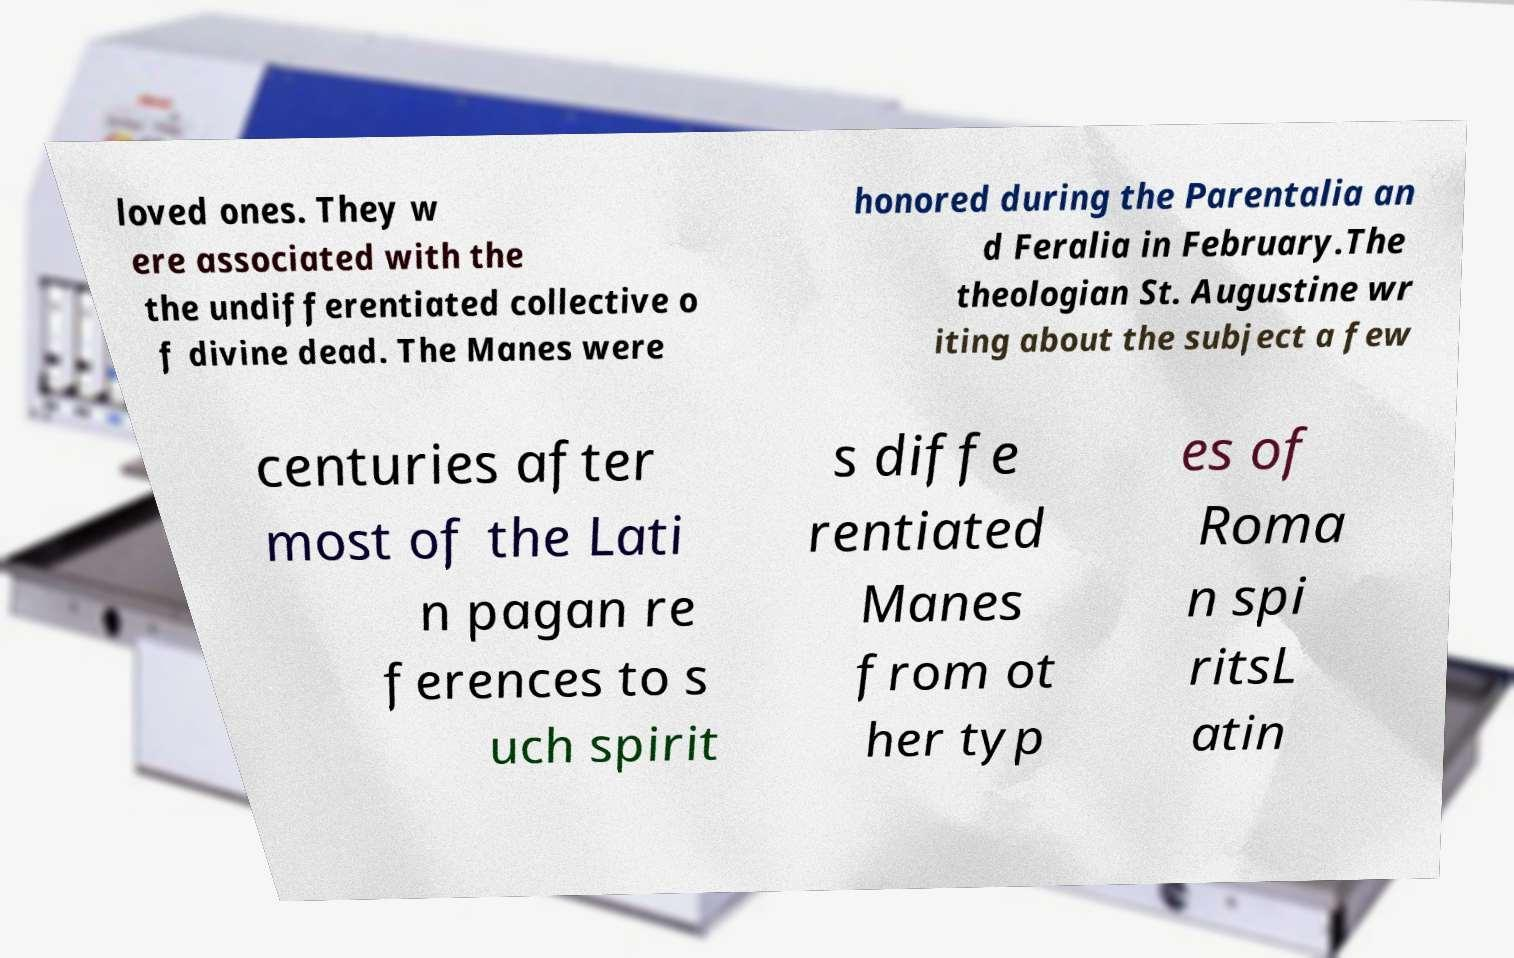There's text embedded in this image that I need extracted. Can you transcribe it verbatim? loved ones. They w ere associated with the the undifferentiated collective o f divine dead. The Manes were honored during the Parentalia an d Feralia in February.The theologian St. Augustine wr iting about the subject a few centuries after most of the Lati n pagan re ferences to s uch spirit s diffe rentiated Manes from ot her typ es of Roma n spi ritsL atin 